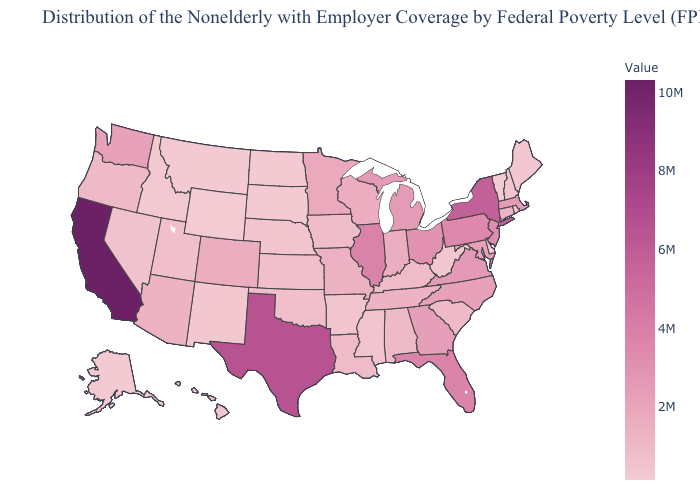Does Mississippi have the lowest value in the USA?
Short answer required. No. Does New York have the highest value in the Northeast?
Short answer required. Yes. Which states have the highest value in the USA?
Write a very short answer. California. 